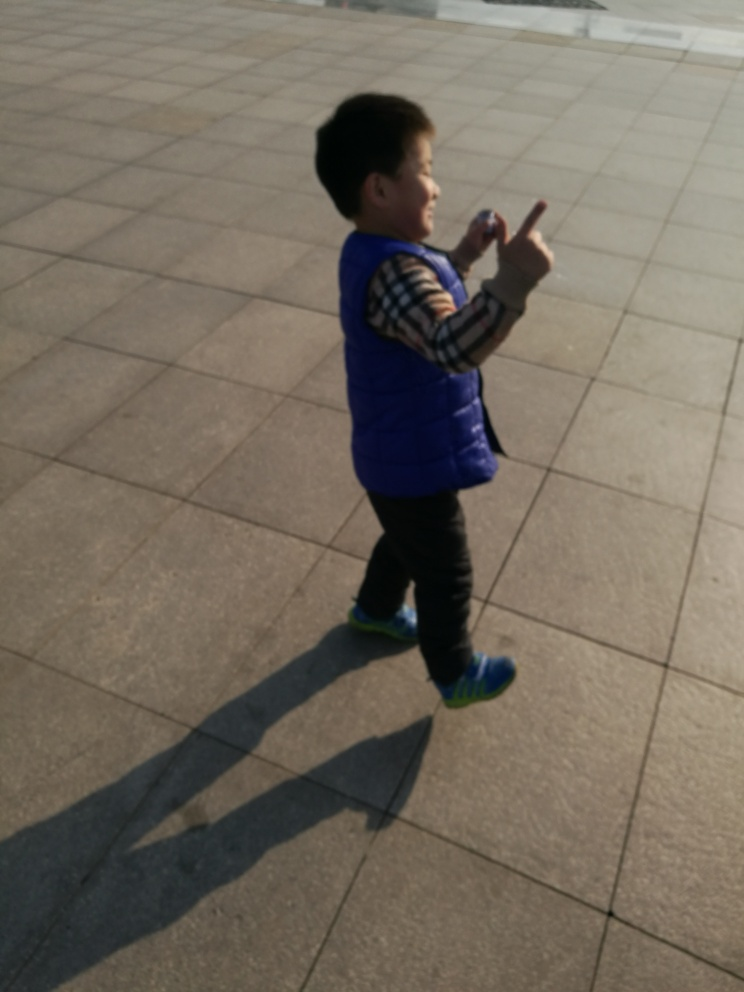Can you describe the child's clothing and appearance? The child is wearing a two-tone blue and plaid sleeve combination vest and a pairs of dark bottoms. The vest looks padded, suggesting it's designed for cooler weather. The child's shoes are bright with green accents, adding a pop of color to the ensemble. The child's hair is short, and his demeanor is lively and animated. 